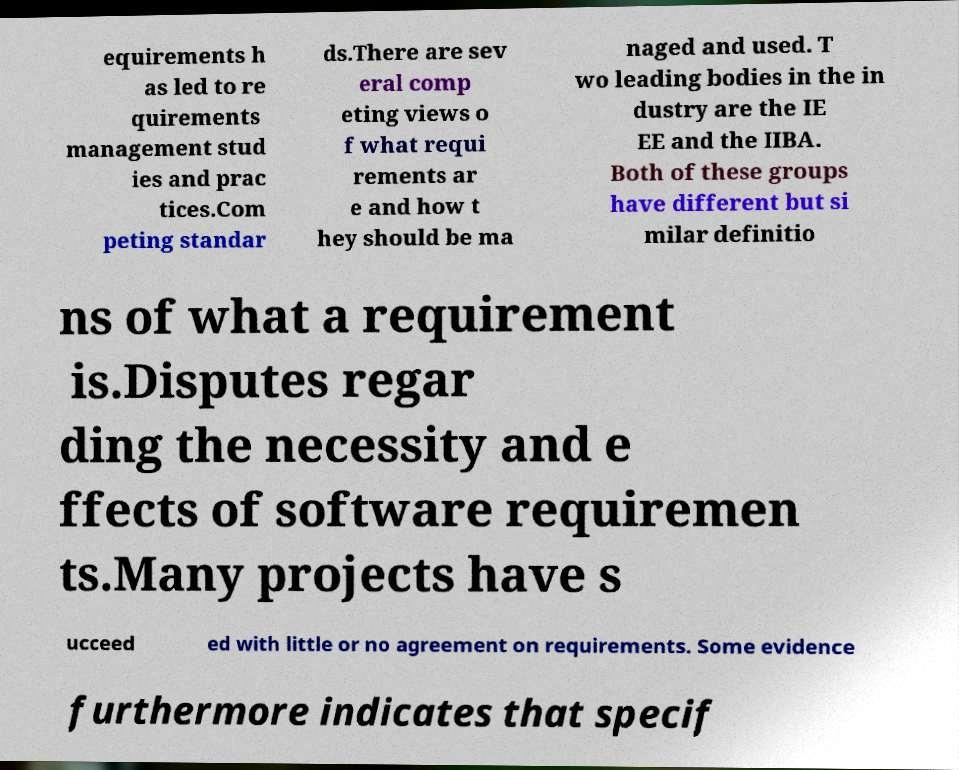Please identify and transcribe the text found in this image. equirements h as led to re quirements management stud ies and prac tices.Com peting standar ds.There are sev eral comp eting views o f what requi rements ar e and how t hey should be ma naged and used. T wo leading bodies in the in dustry are the IE EE and the IIBA. Both of these groups have different but si milar definitio ns of what a requirement is.Disputes regar ding the necessity and e ffects of software requiremen ts.Many projects have s ucceed ed with little or no agreement on requirements. Some evidence furthermore indicates that specif 